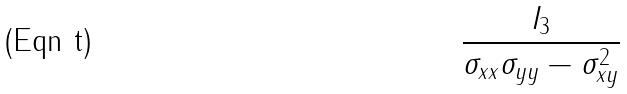Convert formula to latex. <formula><loc_0><loc_0><loc_500><loc_500>\frac { I _ { 3 } } { \sigma _ { x x } \sigma _ { y y } - \sigma _ { x y } ^ { 2 } }</formula> 